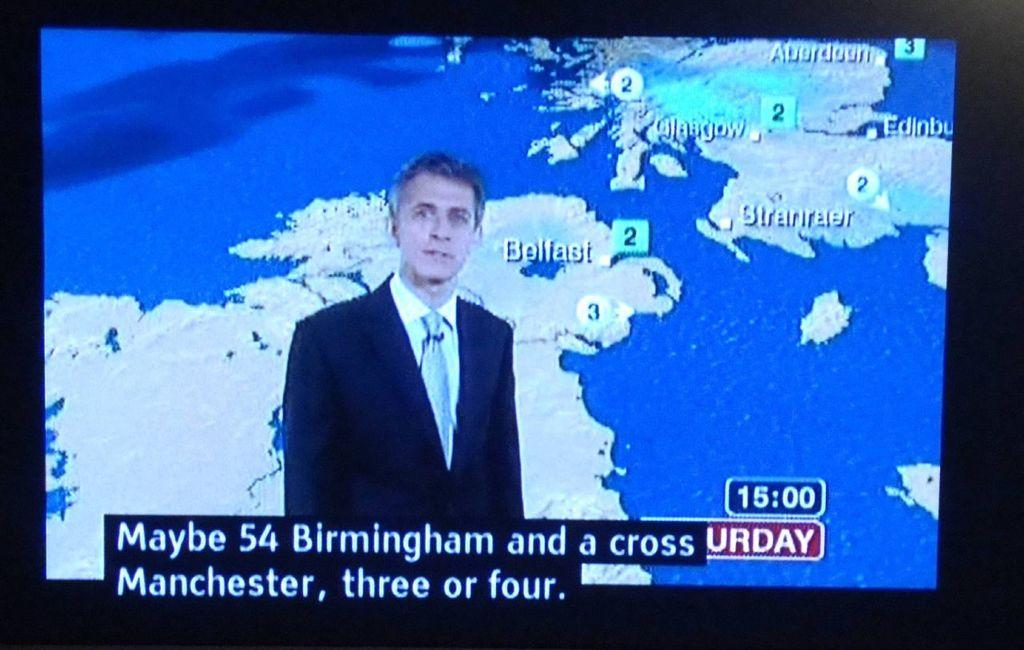<image>
Summarize the visual content of the image. The time shown on the news channel is 15:00 